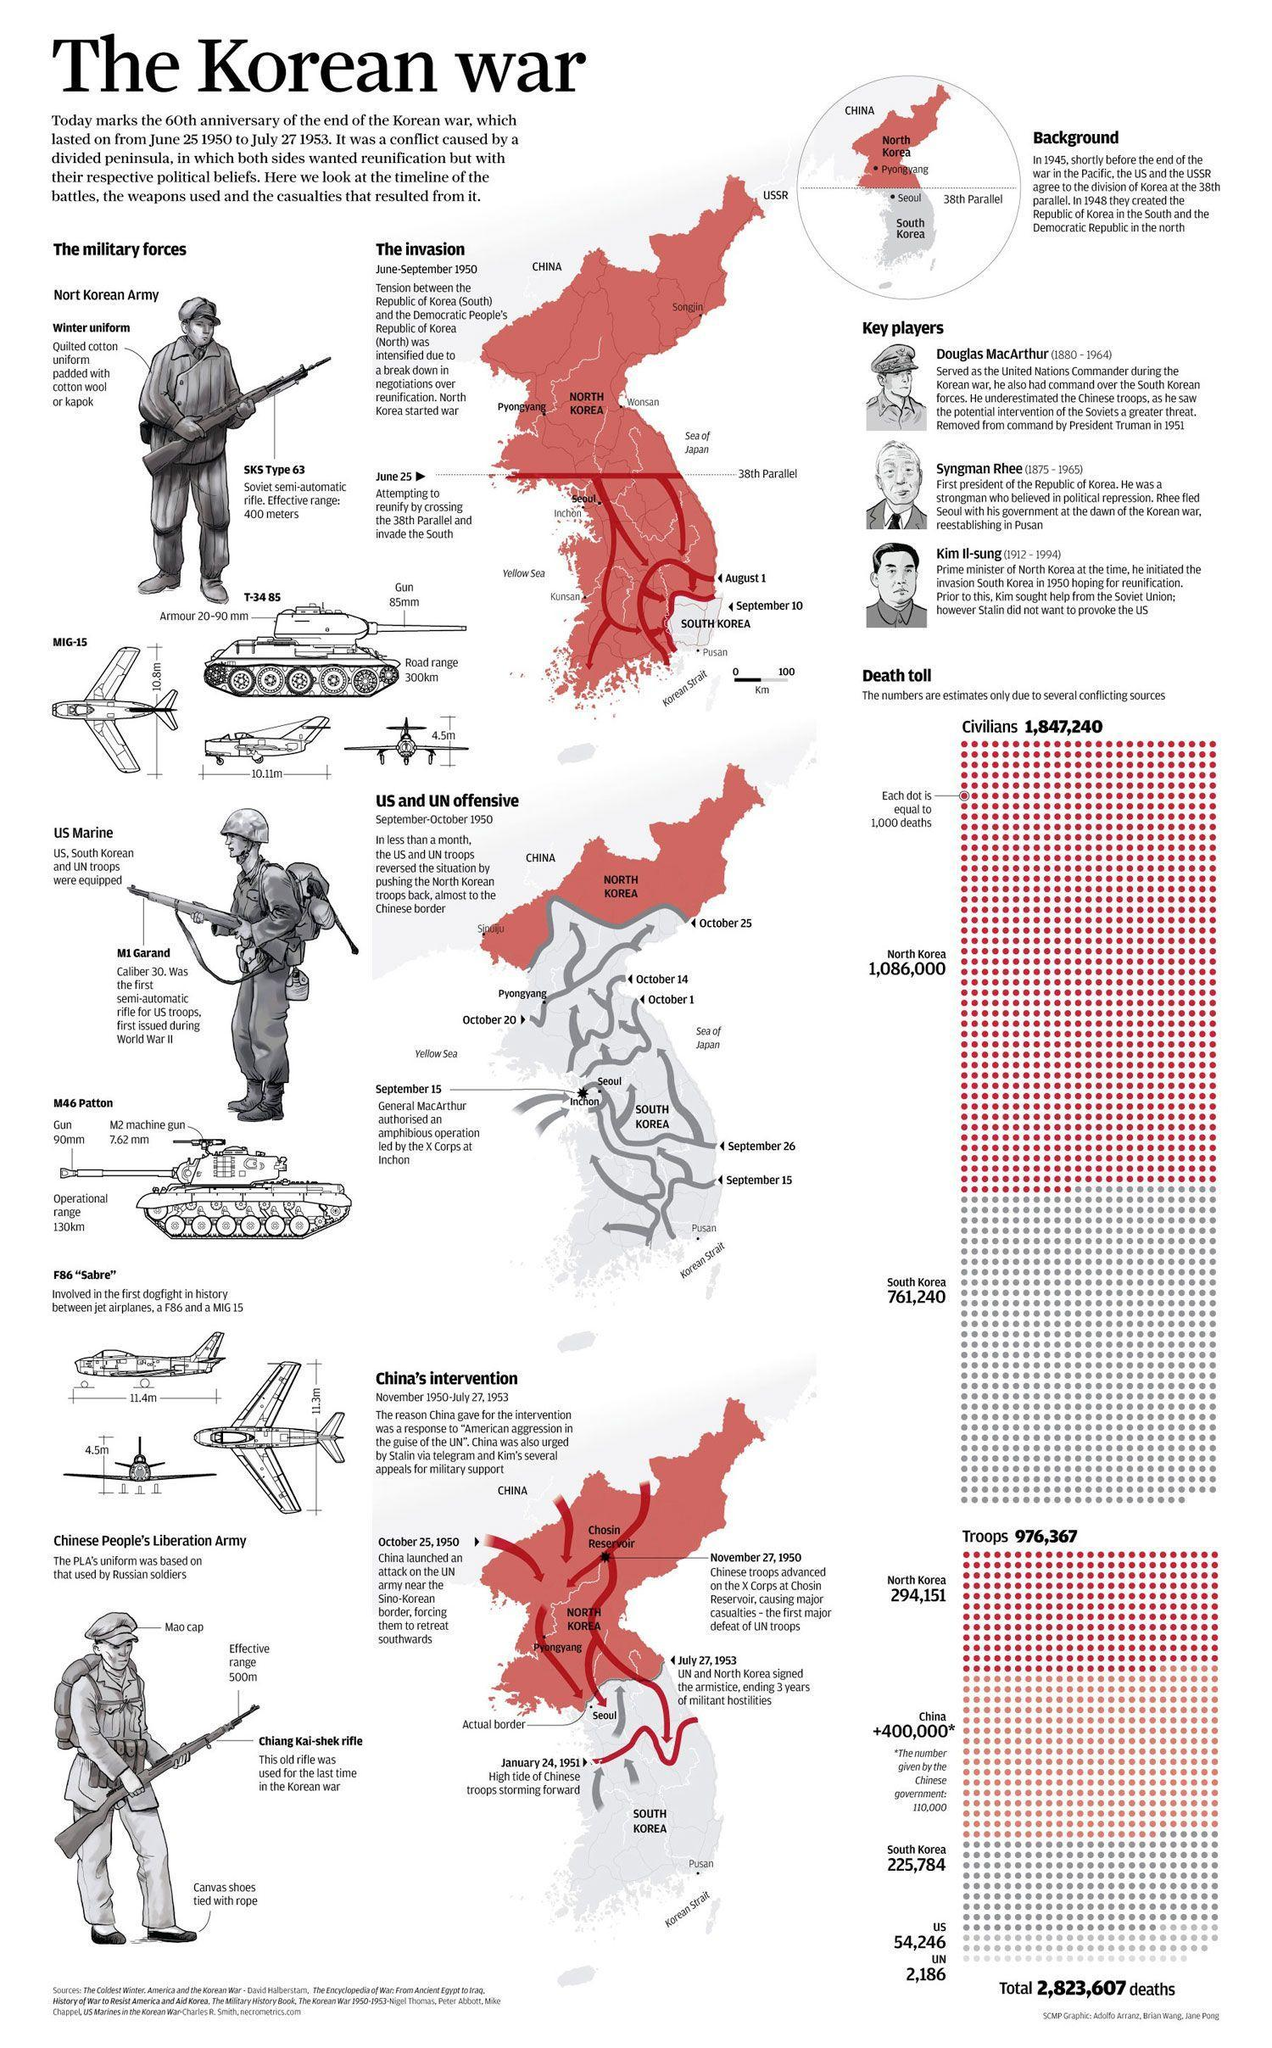How many US military troops casualties were reported during the Korean War?
Answer the question with a short phrase. 54,246 What was the total number of deaths reported in South Korea during the Korean War? 761,240 What is the operational range of M46 Patton? 130km Who was South Korea's first president? Syngman Rhee What is the effective firing range of SKS Type 63 rifle? 400 meters What is the road range of T-34 85? 300km When did the Korean War begin? June 25 1950 